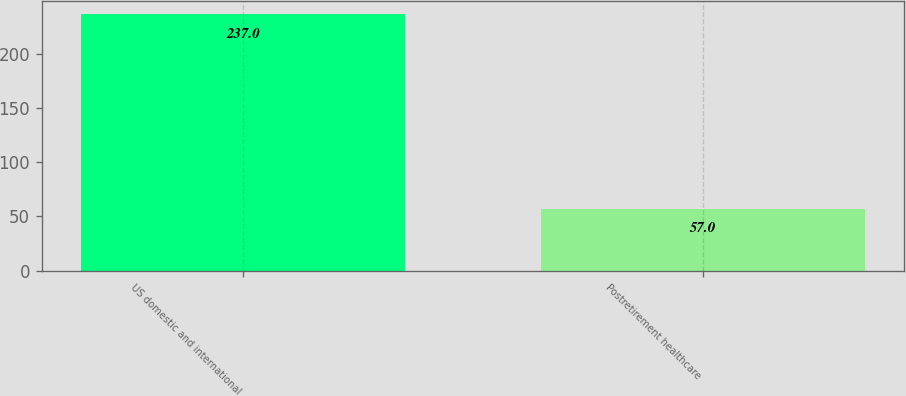<chart> <loc_0><loc_0><loc_500><loc_500><bar_chart><fcel>US domestic and international<fcel>Postretirement healthcare<nl><fcel>237<fcel>57<nl></chart> 